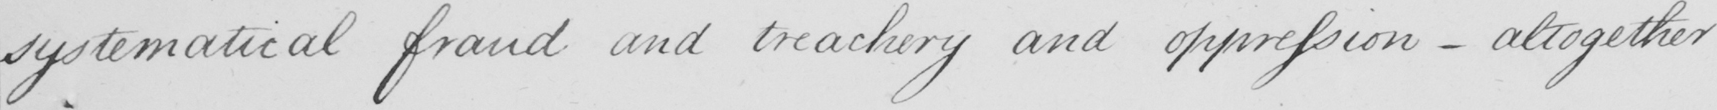Transcribe the text shown in this historical manuscript line. systematical fraud and treachery and oppression  _  altogether 